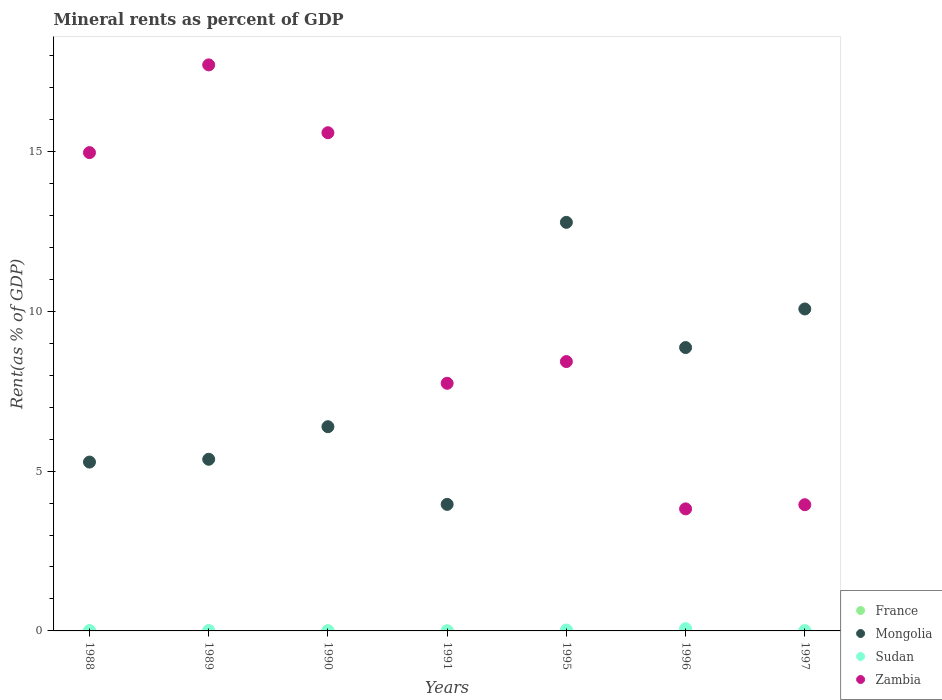What is the mineral rent in Sudan in 1991?
Your answer should be very brief. 0. Across all years, what is the maximum mineral rent in Mongolia?
Provide a succinct answer. 12.78. Across all years, what is the minimum mineral rent in Zambia?
Offer a very short reply. 3.82. In which year was the mineral rent in Sudan minimum?
Offer a terse response. 1991. What is the total mineral rent in Mongolia in the graph?
Provide a short and direct response. 52.72. What is the difference between the mineral rent in Sudan in 1991 and that in 1996?
Provide a short and direct response. -0.07. What is the difference between the mineral rent in France in 1989 and the mineral rent in Zambia in 1997?
Give a very brief answer. -3.94. What is the average mineral rent in France per year?
Ensure brevity in your answer.  0. In the year 1997, what is the difference between the mineral rent in Sudan and mineral rent in Zambia?
Keep it short and to the point. -3.94. In how many years, is the mineral rent in Zambia greater than 17 %?
Your response must be concise. 1. What is the ratio of the mineral rent in France in 1995 to that in 1997?
Your response must be concise. 3.13. Is the mineral rent in Mongolia in 1991 less than that in 1997?
Your response must be concise. Yes. Is the difference between the mineral rent in Sudan in 1988 and 1991 greater than the difference between the mineral rent in Zambia in 1988 and 1991?
Make the answer very short. No. What is the difference between the highest and the second highest mineral rent in Zambia?
Your answer should be very brief. 2.12. What is the difference between the highest and the lowest mineral rent in Sudan?
Your answer should be very brief. 0.07. In how many years, is the mineral rent in Sudan greater than the average mineral rent in Sudan taken over all years?
Provide a succinct answer. 2. Does the mineral rent in Mongolia monotonically increase over the years?
Make the answer very short. No. Is the mineral rent in France strictly less than the mineral rent in Sudan over the years?
Make the answer very short. No. How many years are there in the graph?
Make the answer very short. 7. What is the difference between two consecutive major ticks on the Y-axis?
Provide a short and direct response. 5. Where does the legend appear in the graph?
Your answer should be very brief. Bottom right. What is the title of the graph?
Offer a very short reply. Mineral rents as percent of GDP. What is the label or title of the Y-axis?
Provide a succinct answer. Rent(as % of GDP). What is the Rent(as % of GDP) of France in 1988?
Make the answer very short. 0. What is the Rent(as % of GDP) in Mongolia in 1988?
Offer a very short reply. 5.28. What is the Rent(as % of GDP) of Sudan in 1988?
Make the answer very short. 0.01. What is the Rent(as % of GDP) in Zambia in 1988?
Give a very brief answer. 14.96. What is the Rent(as % of GDP) of France in 1989?
Keep it short and to the point. 0. What is the Rent(as % of GDP) of Mongolia in 1989?
Give a very brief answer. 5.37. What is the Rent(as % of GDP) of Sudan in 1989?
Your response must be concise. 0.01. What is the Rent(as % of GDP) of Zambia in 1989?
Make the answer very short. 17.71. What is the Rent(as % of GDP) in France in 1990?
Your response must be concise. 0. What is the Rent(as % of GDP) of Mongolia in 1990?
Your response must be concise. 6.39. What is the Rent(as % of GDP) in Sudan in 1990?
Make the answer very short. 0. What is the Rent(as % of GDP) of Zambia in 1990?
Provide a short and direct response. 15.59. What is the Rent(as % of GDP) in France in 1991?
Offer a very short reply. 0. What is the Rent(as % of GDP) of Mongolia in 1991?
Ensure brevity in your answer.  3.96. What is the Rent(as % of GDP) of Sudan in 1991?
Offer a terse response. 0. What is the Rent(as % of GDP) of Zambia in 1991?
Make the answer very short. 7.75. What is the Rent(as % of GDP) of France in 1995?
Give a very brief answer. 0. What is the Rent(as % of GDP) of Mongolia in 1995?
Provide a short and direct response. 12.78. What is the Rent(as % of GDP) of Sudan in 1995?
Keep it short and to the point. 0.03. What is the Rent(as % of GDP) in Zambia in 1995?
Make the answer very short. 8.43. What is the Rent(as % of GDP) of France in 1996?
Your answer should be very brief. 0. What is the Rent(as % of GDP) of Mongolia in 1996?
Provide a short and direct response. 8.87. What is the Rent(as % of GDP) of Sudan in 1996?
Give a very brief answer. 0.07. What is the Rent(as % of GDP) in Zambia in 1996?
Your response must be concise. 3.82. What is the Rent(as % of GDP) of France in 1997?
Your response must be concise. 0. What is the Rent(as % of GDP) of Mongolia in 1997?
Your response must be concise. 10.07. What is the Rent(as % of GDP) in Sudan in 1997?
Offer a terse response. 0. What is the Rent(as % of GDP) in Zambia in 1997?
Offer a terse response. 3.95. Across all years, what is the maximum Rent(as % of GDP) in France?
Your response must be concise. 0. Across all years, what is the maximum Rent(as % of GDP) in Mongolia?
Your answer should be very brief. 12.78. Across all years, what is the maximum Rent(as % of GDP) in Sudan?
Offer a terse response. 0.07. Across all years, what is the maximum Rent(as % of GDP) in Zambia?
Ensure brevity in your answer.  17.71. Across all years, what is the minimum Rent(as % of GDP) of France?
Offer a terse response. 0. Across all years, what is the minimum Rent(as % of GDP) in Mongolia?
Provide a short and direct response. 3.96. Across all years, what is the minimum Rent(as % of GDP) of Sudan?
Keep it short and to the point. 0. Across all years, what is the minimum Rent(as % of GDP) of Zambia?
Offer a very short reply. 3.82. What is the total Rent(as % of GDP) of France in the graph?
Provide a short and direct response. 0.01. What is the total Rent(as % of GDP) of Mongolia in the graph?
Make the answer very short. 52.72. What is the total Rent(as % of GDP) of Sudan in the graph?
Give a very brief answer. 0.12. What is the total Rent(as % of GDP) in Zambia in the graph?
Offer a very short reply. 72.2. What is the difference between the Rent(as % of GDP) in France in 1988 and that in 1989?
Provide a succinct answer. -0. What is the difference between the Rent(as % of GDP) in Mongolia in 1988 and that in 1989?
Make the answer very short. -0.09. What is the difference between the Rent(as % of GDP) of Sudan in 1988 and that in 1989?
Provide a short and direct response. -0. What is the difference between the Rent(as % of GDP) of Zambia in 1988 and that in 1989?
Make the answer very short. -2.74. What is the difference between the Rent(as % of GDP) of France in 1988 and that in 1990?
Ensure brevity in your answer.  0. What is the difference between the Rent(as % of GDP) in Mongolia in 1988 and that in 1990?
Your answer should be compact. -1.11. What is the difference between the Rent(as % of GDP) of Sudan in 1988 and that in 1990?
Make the answer very short. 0.01. What is the difference between the Rent(as % of GDP) in Zambia in 1988 and that in 1990?
Your answer should be compact. -0.62. What is the difference between the Rent(as % of GDP) in France in 1988 and that in 1991?
Your response must be concise. 0. What is the difference between the Rent(as % of GDP) in Mongolia in 1988 and that in 1991?
Your answer should be very brief. 1.32. What is the difference between the Rent(as % of GDP) in Sudan in 1988 and that in 1991?
Ensure brevity in your answer.  0.01. What is the difference between the Rent(as % of GDP) of Zambia in 1988 and that in 1991?
Your response must be concise. 7.22. What is the difference between the Rent(as % of GDP) of France in 1988 and that in 1995?
Your answer should be compact. 0. What is the difference between the Rent(as % of GDP) of Mongolia in 1988 and that in 1995?
Ensure brevity in your answer.  -7.5. What is the difference between the Rent(as % of GDP) in Sudan in 1988 and that in 1995?
Ensure brevity in your answer.  -0.02. What is the difference between the Rent(as % of GDP) in Zambia in 1988 and that in 1995?
Your answer should be compact. 6.54. What is the difference between the Rent(as % of GDP) of France in 1988 and that in 1996?
Offer a terse response. 0. What is the difference between the Rent(as % of GDP) of Mongolia in 1988 and that in 1996?
Ensure brevity in your answer.  -3.58. What is the difference between the Rent(as % of GDP) of Sudan in 1988 and that in 1996?
Your response must be concise. -0.06. What is the difference between the Rent(as % of GDP) of Zambia in 1988 and that in 1996?
Offer a very short reply. 11.15. What is the difference between the Rent(as % of GDP) of France in 1988 and that in 1997?
Your answer should be compact. 0. What is the difference between the Rent(as % of GDP) of Mongolia in 1988 and that in 1997?
Offer a very short reply. -4.79. What is the difference between the Rent(as % of GDP) of Sudan in 1988 and that in 1997?
Give a very brief answer. 0. What is the difference between the Rent(as % of GDP) of Zambia in 1988 and that in 1997?
Your answer should be compact. 11.02. What is the difference between the Rent(as % of GDP) in France in 1989 and that in 1990?
Ensure brevity in your answer.  0. What is the difference between the Rent(as % of GDP) of Mongolia in 1989 and that in 1990?
Offer a terse response. -1.02. What is the difference between the Rent(as % of GDP) in Sudan in 1989 and that in 1990?
Provide a succinct answer. 0.01. What is the difference between the Rent(as % of GDP) of Zambia in 1989 and that in 1990?
Provide a succinct answer. 2.12. What is the difference between the Rent(as % of GDP) in France in 1989 and that in 1991?
Offer a terse response. 0. What is the difference between the Rent(as % of GDP) of Mongolia in 1989 and that in 1991?
Keep it short and to the point. 1.41. What is the difference between the Rent(as % of GDP) in Sudan in 1989 and that in 1991?
Your response must be concise. 0.01. What is the difference between the Rent(as % of GDP) of Zambia in 1989 and that in 1991?
Ensure brevity in your answer.  9.96. What is the difference between the Rent(as % of GDP) in France in 1989 and that in 1995?
Offer a very short reply. 0. What is the difference between the Rent(as % of GDP) of Mongolia in 1989 and that in 1995?
Ensure brevity in your answer.  -7.41. What is the difference between the Rent(as % of GDP) in Sudan in 1989 and that in 1995?
Provide a succinct answer. -0.02. What is the difference between the Rent(as % of GDP) of Zambia in 1989 and that in 1995?
Make the answer very short. 9.28. What is the difference between the Rent(as % of GDP) in France in 1989 and that in 1996?
Your answer should be very brief. 0. What is the difference between the Rent(as % of GDP) of Mongolia in 1989 and that in 1996?
Offer a very short reply. -3.5. What is the difference between the Rent(as % of GDP) in Sudan in 1989 and that in 1996?
Keep it short and to the point. -0.06. What is the difference between the Rent(as % of GDP) of Zambia in 1989 and that in 1996?
Provide a short and direct response. 13.89. What is the difference between the Rent(as % of GDP) of France in 1989 and that in 1997?
Provide a short and direct response. 0. What is the difference between the Rent(as % of GDP) in Mongolia in 1989 and that in 1997?
Your response must be concise. -4.7. What is the difference between the Rent(as % of GDP) in Sudan in 1989 and that in 1997?
Provide a short and direct response. 0. What is the difference between the Rent(as % of GDP) in Zambia in 1989 and that in 1997?
Provide a short and direct response. 13.76. What is the difference between the Rent(as % of GDP) in France in 1990 and that in 1991?
Give a very brief answer. 0. What is the difference between the Rent(as % of GDP) in Mongolia in 1990 and that in 1991?
Your response must be concise. 2.43. What is the difference between the Rent(as % of GDP) of Sudan in 1990 and that in 1991?
Make the answer very short. 0. What is the difference between the Rent(as % of GDP) of Zambia in 1990 and that in 1991?
Your answer should be compact. 7.84. What is the difference between the Rent(as % of GDP) of France in 1990 and that in 1995?
Provide a short and direct response. 0. What is the difference between the Rent(as % of GDP) in Mongolia in 1990 and that in 1995?
Give a very brief answer. -6.39. What is the difference between the Rent(as % of GDP) in Sudan in 1990 and that in 1995?
Provide a short and direct response. -0.03. What is the difference between the Rent(as % of GDP) of Zambia in 1990 and that in 1995?
Give a very brief answer. 7.16. What is the difference between the Rent(as % of GDP) of France in 1990 and that in 1996?
Your response must be concise. 0. What is the difference between the Rent(as % of GDP) in Mongolia in 1990 and that in 1996?
Provide a short and direct response. -2.48. What is the difference between the Rent(as % of GDP) of Sudan in 1990 and that in 1996?
Your response must be concise. -0.07. What is the difference between the Rent(as % of GDP) of Zambia in 1990 and that in 1996?
Your answer should be very brief. 11.77. What is the difference between the Rent(as % of GDP) of France in 1990 and that in 1997?
Your answer should be compact. 0. What is the difference between the Rent(as % of GDP) of Mongolia in 1990 and that in 1997?
Offer a very short reply. -3.68. What is the difference between the Rent(as % of GDP) of Sudan in 1990 and that in 1997?
Provide a succinct answer. -0. What is the difference between the Rent(as % of GDP) of Zambia in 1990 and that in 1997?
Your response must be concise. 11.64. What is the difference between the Rent(as % of GDP) of France in 1991 and that in 1995?
Provide a short and direct response. 0. What is the difference between the Rent(as % of GDP) in Mongolia in 1991 and that in 1995?
Your response must be concise. -8.82. What is the difference between the Rent(as % of GDP) of Sudan in 1991 and that in 1995?
Ensure brevity in your answer.  -0.03. What is the difference between the Rent(as % of GDP) in Zambia in 1991 and that in 1995?
Keep it short and to the point. -0.68. What is the difference between the Rent(as % of GDP) of France in 1991 and that in 1996?
Offer a very short reply. 0. What is the difference between the Rent(as % of GDP) in Mongolia in 1991 and that in 1996?
Offer a terse response. -4.91. What is the difference between the Rent(as % of GDP) of Sudan in 1991 and that in 1996?
Your response must be concise. -0.07. What is the difference between the Rent(as % of GDP) of Zambia in 1991 and that in 1996?
Ensure brevity in your answer.  3.93. What is the difference between the Rent(as % of GDP) in France in 1991 and that in 1997?
Provide a succinct answer. 0. What is the difference between the Rent(as % of GDP) of Mongolia in 1991 and that in 1997?
Your answer should be compact. -6.11. What is the difference between the Rent(as % of GDP) in Sudan in 1991 and that in 1997?
Give a very brief answer. -0. What is the difference between the Rent(as % of GDP) of Zambia in 1991 and that in 1997?
Offer a very short reply. 3.8. What is the difference between the Rent(as % of GDP) in France in 1995 and that in 1996?
Your response must be concise. -0. What is the difference between the Rent(as % of GDP) of Mongolia in 1995 and that in 1996?
Provide a succinct answer. 3.92. What is the difference between the Rent(as % of GDP) in Sudan in 1995 and that in 1996?
Your answer should be very brief. -0.04. What is the difference between the Rent(as % of GDP) of Zambia in 1995 and that in 1996?
Keep it short and to the point. 4.61. What is the difference between the Rent(as % of GDP) in Mongolia in 1995 and that in 1997?
Give a very brief answer. 2.71. What is the difference between the Rent(as % of GDP) of Sudan in 1995 and that in 1997?
Your answer should be compact. 0.02. What is the difference between the Rent(as % of GDP) of Zambia in 1995 and that in 1997?
Keep it short and to the point. 4.48. What is the difference between the Rent(as % of GDP) in France in 1996 and that in 1997?
Provide a succinct answer. 0. What is the difference between the Rent(as % of GDP) of Mongolia in 1996 and that in 1997?
Offer a terse response. -1.21. What is the difference between the Rent(as % of GDP) of Sudan in 1996 and that in 1997?
Provide a succinct answer. 0.07. What is the difference between the Rent(as % of GDP) of Zambia in 1996 and that in 1997?
Your response must be concise. -0.13. What is the difference between the Rent(as % of GDP) of France in 1988 and the Rent(as % of GDP) of Mongolia in 1989?
Provide a short and direct response. -5.37. What is the difference between the Rent(as % of GDP) of France in 1988 and the Rent(as % of GDP) of Sudan in 1989?
Your response must be concise. -0. What is the difference between the Rent(as % of GDP) in France in 1988 and the Rent(as % of GDP) in Zambia in 1989?
Your answer should be very brief. -17.71. What is the difference between the Rent(as % of GDP) in Mongolia in 1988 and the Rent(as % of GDP) in Sudan in 1989?
Provide a succinct answer. 5.27. What is the difference between the Rent(as % of GDP) in Mongolia in 1988 and the Rent(as % of GDP) in Zambia in 1989?
Your answer should be compact. -12.43. What is the difference between the Rent(as % of GDP) of Sudan in 1988 and the Rent(as % of GDP) of Zambia in 1989?
Offer a terse response. -17.7. What is the difference between the Rent(as % of GDP) in France in 1988 and the Rent(as % of GDP) in Mongolia in 1990?
Offer a terse response. -6.39. What is the difference between the Rent(as % of GDP) of France in 1988 and the Rent(as % of GDP) of Sudan in 1990?
Ensure brevity in your answer.  0. What is the difference between the Rent(as % of GDP) of France in 1988 and the Rent(as % of GDP) of Zambia in 1990?
Offer a terse response. -15.58. What is the difference between the Rent(as % of GDP) of Mongolia in 1988 and the Rent(as % of GDP) of Sudan in 1990?
Your answer should be compact. 5.28. What is the difference between the Rent(as % of GDP) in Mongolia in 1988 and the Rent(as % of GDP) in Zambia in 1990?
Make the answer very short. -10.3. What is the difference between the Rent(as % of GDP) in Sudan in 1988 and the Rent(as % of GDP) in Zambia in 1990?
Make the answer very short. -15.58. What is the difference between the Rent(as % of GDP) in France in 1988 and the Rent(as % of GDP) in Mongolia in 1991?
Provide a succinct answer. -3.96. What is the difference between the Rent(as % of GDP) of France in 1988 and the Rent(as % of GDP) of Sudan in 1991?
Ensure brevity in your answer.  0. What is the difference between the Rent(as % of GDP) in France in 1988 and the Rent(as % of GDP) in Zambia in 1991?
Make the answer very short. -7.74. What is the difference between the Rent(as % of GDP) in Mongolia in 1988 and the Rent(as % of GDP) in Sudan in 1991?
Offer a very short reply. 5.28. What is the difference between the Rent(as % of GDP) in Mongolia in 1988 and the Rent(as % of GDP) in Zambia in 1991?
Your answer should be compact. -2.46. What is the difference between the Rent(as % of GDP) in Sudan in 1988 and the Rent(as % of GDP) in Zambia in 1991?
Offer a terse response. -7.74. What is the difference between the Rent(as % of GDP) in France in 1988 and the Rent(as % of GDP) in Mongolia in 1995?
Give a very brief answer. -12.78. What is the difference between the Rent(as % of GDP) in France in 1988 and the Rent(as % of GDP) in Sudan in 1995?
Provide a short and direct response. -0.03. What is the difference between the Rent(as % of GDP) in France in 1988 and the Rent(as % of GDP) in Zambia in 1995?
Provide a short and direct response. -8.42. What is the difference between the Rent(as % of GDP) in Mongolia in 1988 and the Rent(as % of GDP) in Sudan in 1995?
Make the answer very short. 5.25. What is the difference between the Rent(as % of GDP) in Mongolia in 1988 and the Rent(as % of GDP) in Zambia in 1995?
Keep it short and to the point. -3.14. What is the difference between the Rent(as % of GDP) of Sudan in 1988 and the Rent(as % of GDP) of Zambia in 1995?
Your response must be concise. -8.42. What is the difference between the Rent(as % of GDP) in France in 1988 and the Rent(as % of GDP) in Mongolia in 1996?
Offer a very short reply. -8.86. What is the difference between the Rent(as % of GDP) in France in 1988 and the Rent(as % of GDP) in Sudan in 1996?
Offer a terse response. -0.07. What is the difference between the Rent(as % of GDP) of France in 1988 and the Rent(as % of GDP) of Zambia in 1996?
Your answer should be very brief. -3.81. What is the difference between the Rent(as % of GDP) in Mongolia in 1988 and the Rent(as % of GDP) in Sudan in 1996?
Your answer should be very brief. 5.21. What is the difference between the Rent(as % of GDP) in Mongolia in 1988 and the Rent(as % of GDP) in Zambia in 1996?
Ensure brevity in your answer.  1.46. What is the difference between the Rent(as % of GDP) of Sudan in 1988 and the Rent(as % of GDP) of Zambia in 1996?
Offer a very short reply. -3.81. What is the difference between the Rent(as % of GDP) in France in 1988 and the Rent(as % of GDP) in Mongolia in 1997?
Provide a succinct answer. -10.07. What is the difference between the Rent(as % of GDP) of France in 1988 and the Rent(as % of GDP) of Sudan in 1997?
Your response must be concise. -0. What is the difference between the Rent(as % of GDP) in France in 1988 and the Rent(as % of GDP) in Zambia in 1997?
Keep it short and to the point. -3.94. What is the difference between the Rent(as % of GDP) of Mongolia in 1988 and the Rent(as % of GDP) of Sudan in 1997?
Ensure brevity in your answer.  5.28. What is the difference between the Rent(as % of GDP) in Mongolia in 1988 and the Rent(as % of GDP) in Zambia in 1997?
Your answer should be compact. 1.33. What is the difference between the Rent(as % of GDP) in Sudan in 1988 and the Rent(as % of GDP) in Zambia in 1997?
Keep it short and to the point. -3.94. What is the difference between the Rent(as % of GDP) of France in 1989 and the Rent(as % of GDP) of Mongolia in 1990?
Provide a succinct answer. -6.38. What is the difference between the Rent(as % of GDP) of France in 1989 and the Rent(as % of GDP) of Sudan in 1990?
Your answer should be very brief. 0. What is the difference between the Rent(as % of GDP) of France in 1989 and the Rent(as % of GDP) of Zambia in 1990?
Give a very brief answer. -15.58. What is the difference between the Rent(as % of GDP) of Mongolia in 1989 and the Rent(as % of GDP) of Sudan in 1990?
Your answer should be compact. 5.37. What is the difference between the Rent(as % of GDP) in Mongolia in 1989 and the Rent(as % of GDP) in Zambia in 1990?
Offer a terse response. -10.22. What is the difference between the Rent(as % of GDP) of Sudan in 1989 and the Rent(as % of GDP) of Zambia in 1990?
Provide a short and direct response. -15.58. What is the difference between the Rent(as % of GDP) in France in 1989 and the Rent(as % of GDP) in Mongolia in 1991?
Provide a succinct answer. -3.96. What is the difference between the Rent(as % of GDP) in France in 1989 and the Rent(as % of GDP) in Sudan in 1991?
Offer a very short reply. 0. What is the difference between the Rent(as % of GDP) of France in 1989 and the Rent(as % of GDP) of Zambia in 1991?
Offer a very short reply. -7.74. What is the difference between the Rent(as % of GDP) of Mongolia in 1989 and the Rent(as % of GDP) of Sudan in 1991?
Your answer should be compact. 5.37. What is the difference between the Rent(as % of GDP) of Mongolia in 1989 and the Rent(as % of GDP) of Zambia in 1991?
Offer a terse response. -2.38. What is the difference between the Rent(as % of GDP) of Sudan in 1989 and the Rent(as % of GDP) of Zambia in 1991?
Provide a succinct answer. -7.74. What is the difference between the Rent(as % of GDP) in France in 1989 and the Rent(as % of GDP) in Mongolia in 1995?
Ensure brevity in your answer.  -12.78. What is the difference between the Rent(as % of GDP) of France in 1989 and the Rent(as % of GDP) of Sudan in 1995?
Provide a short and direct response. -0.03. What is the difference between the Rent(as % of GDP) in France in 1989 and the Rent(as % of GDP) in Zambia in 1995?
Offer a very short reply. -8.42. What is the difference between the Rent(as % of GDP) of Mongolia in 1989 and the Rent(as % of GDP) of Sudan in 1995?
Offer a very short reply. 5.34. What is the difference between the Rent(as % of GDP) of Mongolia in 1989 and the Rent(as % of GDP) of Zambia in 1995?
Your response must be concise. -3.06. What is the difference between the Rent(as % of GDP) in Sudan in 1989 and the Rent(as % of GDP) in Zambia in 1995?
Your answer should be compact. -8.42. What is the difference between the Rent(as % of GDP) of France in 1989 and the Rent(as % of GDP) of Mongolia in 1996?
Offer a very short reply. -8.86. What is the difference between the Rent(as % of GDP) in France in 1989 and the Rent(as % of GDP) in Sudan in 1996?
Your answer should be compact. -0.07. What is the difference between the Rent(as % of GDP) of France in 1989 and the Rent(as % of GDP) of Zambia in 1996?
Your answer should be very brief. -3.81. What is the difference between the Rent(as % of GDP) in Mongolia in 1989 and the Rent(as % of GDP) in Sudan in 1996?
Provide a short and direct response. 5.3. What is the difference between the Rent(as % of GDP) in Mongolia in 1989 and the Rent(as % of GDP) in Zambia in 1996?
Your response must be concise. 1.55. What is the difference between the Rent(as % of GDP) of Sudan in 1989 and the Rent(as % of GDP) of Zambia in 1996?
Keep it short and to the point. -3.81. What is the difference between the Rent(as % of GDP) of France in 1989 and the Rent(as % of GDP) of Mongolia in 1997?
Your response must be concise. -10.07. What is the difference between the Rent(as % of GDP) of France in 1989 and the Rent(as % of GDP) of Sudan in 1997?
Keep it short and to the point. -0. What is the difference between the Rent(as % of GDP) in France in 1989 and the Rent(as % of GDP) in Zambia in 1997?
Provide a short and direct response. -3.94. What is the difference between the Rent(as % of GDP) in Mongolia in 1989 and the Rent(as % of GDP) in Sudan in 1997?
Give a very brief answer. 5.37. What is the difference between the Rent(as % of GDP) of Mongolia in 1989 and the Rent(as % of GDP) of Zambia in 1997?
Offer a terse response. 1.42. What is the difference between the Rent(as % of GDP) of Sudan in 1989 and the Rent(as % of GDP) of Zambia in 1997?
Your answer should be compact. -3.94. What is the difference between the Rent(as % of GDP) in France in 1990 and the Rent(as % of GDP) in Mongolia in 1991?
Ensure brevity in your answer.  -3.96. What is the difference between the Rent(as % of GDP) in France in 1990 and the Rent(as % of GDP) in Sudan in 1991?
Provide a succinct answer. 0. What is the difference between the Rent(as % of GDP) in France in 1990 and the Rent(as % of GDP) in Zambia in 1991?
Provide a short and direct response. -7.75. What is the difference between the Rent(as % of GDP) in Mongolia in 1990 and the Rent(as % of GDP) in Sudan in 1991?
Offer a terse response. 6.39. What is the difference between the Rent(as % of GDP) of Mongolia in 1990 and the Rent(as % of GDP) of Zambia in 1991?
Ensure brevity in your answer.  -1.36. What is the difference between the Rent(as % of GDP) of Sudan in 1990 and the Rent(as % of GDP) of Zambia in 1991?
Keep it short and to the point. -7.75. What is the difference between the Rent(as % of GDP) in France in 1990 and the Rent(as % of GDP) in Mongolia in 1995?
Your answer should be compact. -12.78. What is the difference between the Rent(as % of GDP) of France in 1990 and the Rent(as % of GDP) of Sudan in 1995?
Offer a very short reply. -0.03. What is the difference between the Rent(as % of GDP) of France in 1990 and the Rent(as % of GDP) of Zambia in 1995?
Keep it short and to the point. -8.42. What is the difference between the Rent(as % of GDP) in Mongolia in 1990 and the Rent(as % of GDP) in Sudan in 1995?
Your answer should be very brief. 6.36. What is the difference between the Rent(as % of GDP) of Mongolia in 1990 and the Rent(as % of GDP) of Zambia in 1995?
Provide a succinct answer. -2.04. What is the difference between the Rent(as % of GDP) in Sudan in 1990 and the Rent(as % of GDP) in Zambia in 1995?
Give a very brief answer. -8.42. What is the difference between the Rent(as % of GDP) in France in 1990 and the Rent(as % of GDP) in Mongolia in 1996?
Your answer should be compact. -8.86. What is the difference between the Rent(as % of GDP) of France in 1990 and the Rent(as % of GDP) of Sudan in 1996?
Your response must be concise. -0.07. What is the difference between the Rent(as % of GDP) in France in 1990 and the Rent(as % of GDP) in Zambia in 1996?
Ensure brevity in your answer.  -3.82. What is the difference between the Rent(as % of GDP) of Mongolia in 1990 and the Rent(as % of GDP) of Sudan in 1996?
Your answer should be very brief. 6.32. What is the difference between the Rent(as % of GDP) of Mongolia in 1990 and the Rent(as % of GDP) of Zambia in 1996?
Ensure brevity in your answer.  2.57. What is the difference between the Rent(as % of GDP) of Sudan in 1990 and the Rent(as % of GDP) of Zambia in 1996?
Offer a terse response. -3.82. What is the difference between the Rent(as % of GDP) of France in 1990 and the Rent(as % of GDP) of Mongolia in 1997?
Give a very brief answer. -10.07. What is the difference between the Rent(as % of GDP) in France in 1990 and the Rent(as % of GDP) in Sudan in 1997?
Keep it short and to the point. -0. What is the difference between the Rent(as % of GDP) in France in 1990 and the Rent(as % of GDP) in Zambia in 1997?
Keep it short and to the point. -3.95. What is the difference between the Rent(as % of GDP) in Mongolia in 1990 and the Rent(as % of GDP) in Sudan in 1997?
Your answer should be compact. 6.38. What is the difference between the Rent(as % of GDP) of Mongolia in 1990 and the Rent(as % of GDP) of Zambia in 1997?
Offer a very short reply. 2.44. What is the difference between the Rent(as % of GDP) in Sudan in 1990 and the Rent(as % of GDP) in Zambia in 1997?
Keep it short and to the point. -3.95. What is the difference between the Rent(as % of GDP) in France in 1991 and the Rent(as % of GDP) in Mongolia in 1995?
Your answer should be very brief. -12.78. What is the difference between the Rent(as % of GDP) of France in 1991 and the Rent(as % of GDP) of Sudan in 1995?
Ensure brevity in your answer.  -0.03. What is the difference between the Rent(as % of GDP) in France in 1991 and the Rent(as % of GDP) in Zambia in 1995?
Your response must be concise. -8.43. What is the difference between the Rent(as % of GDP) in Mongolia in 1991 and the Rent(as % of GDP) in Sudan in 1995?
Ensure brevity in your answer.  3.93. What is the difference between the Rent(as % of GDP) in Mongolia in 1991 and the Rent(as % of GDP) in Zambia in 1995?
Provide a succinct answer. -4.47. What is the difference between the Rent(as % of GDP) of Sudan in 1991 and the Rent(as % of GDP) of Zambia in 1995?
Your response must be concise. -8.43. What is the difference between the Rent(as % of GDP) of France in 1991 and the Rent(as % of GDP) of Mongolia in 1996?
Provide a succinct answer. -8.86. What is the difference between the Rent(as % of GDP) in France in 1991 and the Rent(as % of GDP) in Sudan in 1996?
Your answer should be compact. -0.07. What is the difference between the Rent(as % of GDP) in France in 1991 and the Rent(as % of GDP) in Zambia in 1996?
Ensure brevity in your answer.  -3.82. What is the difference between the Rent(as % of GDP) of Mongolia in 1991 and the Rent(as % of GDP) of Sudan in 1996?
Your answer should be very brief. 3.89. What is the difference between the Rent(as % of GDP) of Mongolia in 1991 and the Rent(as % of GDP) of Zambia in 1996?
Provide a short and direct response. 0.14. What is the difference between the Rent(as % of GDP) in Sudan in 1991 and the Rent(as % of GDP) in Zambia in 1996?
Your answer should be compact. -3.82. What is the difference between the Rent(as % of GDP) in France in 1991 and the Rent(as % of GDP) in Mongolia in 1997?
Your answer should be very brief. -10.07. What is the difference between the Rent(as % of GDP) of France in 1991 and the Rent(as % of GDP) of Sudan in 1997?
Your answer should be very brief. -0. What is the difference between the Rent(as % of GDP) in France in 1991 and the Rent(as % of GDP) in Zambia in 1997?
Your answer should be very brief. -3.95. What is the difference between the Rent(as % of GDP) in Mongolia in 1991 and the Rent(as % of GDP) in Sudan in 1997?
Your answer should be very brief. 3.95. What is the difference between the Rent(as % of GDP) in Mongolia in 1991 and the Rent(as % of GDP) in Zambia in 1997?
Your answer should be very brief. 0.01. What is the difference between the Rent(as % of GDP) of Sudan in 1991 and the Rent(as % of GDP) of Zambia in 1997?
Ensure brevity in your answer.  -3.95. What is the difference between the Rent(as % of GDP) in France in 1995 and the Rent(as % of GDP) in Mongolia in 1996?
Keep it short and to the point. -8.87. What is the difference between the Rent(as % of GDP) of France in 1995 and the Rent(as % of GDP) of Sudan in 1996?
Provide a short and direct response. -0.07. What is the difference between the Rent(as % of GDP) of France in 1995 and the Rent(as % of GDP) of Zambia in 1996?
Provide a short and direct response. -3.82. What is the difference between the Rent(as % of GDP) in Mongolia in 1995 and the Rent(as % of GDP) in Sudan in 1996?
Your answer should be very brief. 12.71. What is the difference between the Rent(as % of GDP) in Mongolia in 1995 and the Rent(as % of GDP) in Zambia in 1996?
Your response must be concise. 8.96. What is the difference between the Rent(as % of GDP) of Sudan in 1995 and the Rent(as % of GDP) of Zambia in 1996?
Provide a succinct answer. -3.79. What is the difference between the Rent(as % of GDP) in France in 1995 and the Rent(as % of GDP) in Mongolia in 1997?
Keep it short and to the point. -10.07. What is the difference between the Rent(as % of GDP) in France in 1995 and the Rent(as % of GDP) in Sudan in 1997?
Your answer should be very brief. -0. What is the difference between the Rent(as % of GDP) of France in 1995 and the Rent(as % of GDP) of Zambia in 1997?
Offer a terse response. -3.95. What is the difference between the Rent(as % of GDP) of Mongolia in 1995 and the Rent(as % of GDP) of Sudan in 1997?
Provide a short and direct response. 12.78. What is the difference between the Rent(as % of GDP) of Mongolia in 1995 and the Rent(as % of GDP) of Zambia in 1997?
Provide a succinct answer. 8.83. What is the difference between the Rent(as % of GDP) in Sudan in 1995 and the Rent(as % of GDP) in Zambia in 1997?
Provide a succinct answer. -3.92. What is the difference between the Rent(as % of GDP) in France in 1996 and the Rent(as % of GDP) in Mongolia in 1997?
Ensure brevity in your answer.  -10.07. What is the difference between the Rent(as % of GDP) of France in 1996 and the Rent(as % of GDP) of Sudan in 1997?
Offer a terse response. -0. What is the difference between the Rent(as % of GDP) in France in 1996 and the Rent(as % of GDP) in Zambia in 1997?
Provide a succinct answer. -3.95. What is the difference between the Rent(as % of GDP) in Mongolia in 1996 and the Rent(as % of GDP) in Sudan in 1997?
Give a very brief answer. 8.86. What is the difference between the Rent(as % of GDP) in Mongolia in 1996 and the Rent(as % of GDP) in Zambia in 1997?
Offer a very short reply. 4.92. What is the difference between the Rent(as % of GDP) of Sudan in 1996 and the Rent(as % of GDP) of Zambia in 1997?
Offer a very short reply. -3.88. What is the average Rent(as % of GDP) of France per year?
Make the answer very short. 0. What is the average Rent(as % of GDP) in Mongolia per year?
Offer a very short reply. 7.53. What is the average Rent(as % of GDP) in Sudan per year?
Make the answer very short. 0.02. What is the average Rent(as % of GDP) of Zambia per year?
Ensure brevity in your answer.  10.31. In the year 1988, what is the difference between the Rent(as % of GDP) of France and Rent(as % of GDP) of Mongolia?
Give a very brief answer. -5.28. In the year 1988, what is the difference between the Rent(as % of GDP) of France and Rent(as % of GDP) of Sudan?
Your answer should be compact. -0. In the year 1988, what is the difference between the Rent(as % of GDP) of France and Rent(as % of GDP) of Zambia?
Provide a succinct answer. -14.96. In the year 1988, what is the difference between the Rent(as % of GDP) in Mongolia and Rent(as % of GDP) in Sudan?
Provide a succinct answer. 5.27. In the year 1988, what is the difference between the Rent(as % of GDP) in Mongolia and Rent(as % of GDP) in Zambia?
Give a very brief answer. -9.68. In the year 1988, what is the difference between the Rent(as % of GDP) in Sudan and Rent(as % of GDP) in Zambia?
Give a very brief answer. -14.96. In the year 1989, what is the difference between the Rent(as % of GDP) in France and Rent(as % of GDP) in Mongolia?
Keep it short and to the point. -5.37. In the year 1989, what is the difference between the Rent(as % of GDP) in France and Rent(as % of GDP) in Sudan?
Make the answer very short. -0. In the year 1989, what is the difference between the Rent(as % of GDP) in France and Rent(as % of GDP) in Zambia?
Your answer should be very brief. -17.7. In the year 1989, what is the difference between the Rent(as % of GDP) of Mongolia and Rent(as % of GDP) of Sudan?
Your answer should be compact. 5.36. In the year 1989, what is the difference between the Rent(as % of GDP) of Mongolia and Rent(as % of GDP) of Zambia?
Provide a succinct answer. -12.34. In the year 1989, what is the difference between the Rent(as % of GDP) in Sudan and Rent(as % of GDP) in Zambia?
Your answer should be compact. -17.7. In the year 1990, what is the difference between the Rent(as % of GDP) of France and Rent(as % of GDP) of Mongolia?
Offer a terse response. -6.39. In the year 1990, what is the difference between the Rent(as % of GDP) in France and Rent(as % of GDP) in Sudan?
Provide a succinct answer. 0. In the year 1990, what is the difference between the Rent(as % of GDP) of France and Rent(as % of GDP) of Zambia?
Your answer should be very brief. -15.58. In the year 1990, what is the difference between the Rent(as % of GDP) in Mongolia and Rent(as % of GDP) in Sudan?
Offer a terse response. 6.39. In the year 1990, what is the difference between the Rent(as % of GDP) in Mongolia and Rent(as % of GDP) in Zambia?
Offer a terse response. -9.2. In the year 1990, what is the difference between the Rent(as % of GDP) in Sudan and Rent(as % of GDP) in Zambia?
Give a very brief answer. -15.58. In the year 1991, what is the difference between the Rent(as % of GDP) in France and Rent(as % of GDP) in Mongolia?
Ensure brevity in your answer.  -3.96. In the year 1991, what is the difference between the Rent(as % of GDP) in France and Rent(as % of GDP) in Zambia?
Provide a short and direct response. -7.75. In the year 1991, what is the difference between the Rent(as % of GDP) in Mongolia and Rent(as % of GDP) in Sudan?
Ensure brevity in your answer.  3.96. In the year 1991, what is the difference between the Rent(as % of GDP) in Mongolia and Rent(as % of GDP) in Zambia?
Make the answer very short. -3.79. In the year 1991, what is the difference between the Rent(as % of GDP) of Sudan and Rent(as % of GDP) of Zambia?
Offer a terse response. -7.75. In the year 1995, what is the difference between the Rent(as % of GDP) in France and Rent(as % of GDP) in Mongolia?
Your answer should be very brief. -12.78. In the year 1995, what is the difference between the Rent(as % of GDP) of France and Rent(as % of GDP) of Sudan?
Offer a very short reply. -0.03. In the year 1995, what is the difference between the Rent(as % of GDP) of France and Rent(as % of GDP) of Zambia?
Your answer should be very brief. -8.43. In the year 1995, what is the difference between the Rent(as % of GDP) in Mongolia and Rent(as % of GDP) in Sudan?
Keep it short and to the point. 12.75. In the year 1995, what is the difference between the Rent(as % of GDP) of Mongolia and Rent(as % of GDP) of Zambia?
Offer a very short reply. 4.36. In the year 1995, what is the difference between the Rent(as % of GDP) of Sudan and Rent(as % of GDP) of Zambia?
Give a very brief answer. -8.4. In the year 1996, what is the difference between the Rent(as % of GDP) of France and Rent(as % of GDP) of Mongolia?
Your response must be concise. -8.86. In the year 1996, what is the difference between the Rent(as % of GDP) in France and Rent(as % of GDP) in Sudan?
Make the answer very short. -0.07. In the year 1996, what is the difference between the Rent(as % of GDP) of France and Rent(as % of GDP) of Zambia?
Keep it short and to the point. -3.82. In the year 1996, what is the difference between the Rent(as % of GDP) in Mongolia and Rent(as % of GDP) in Sudan?
Provide a short and direct response. 8.79. In the year 1996, what is the difference between the Rent(as % of GDP) of Mongolia and Rent(as % of GDP) of Zambia?
Offer a terse response. 5.05. In the year 1996, what is the difference between the Rent(as % of GDP) in Sudan and Rent(as % of GDP) in Zambia?
Keep it short and to the point. -3.75. In the year 1997, what is the difference between the Rent(as % of GDP) of France and Rent(as % of GDP) of Mongolia?
Give a very brief answer. -10.07. In the year 1997, what is the difference between the Rent(as % of GDP) in France and Rent(as % of GDP) in Sudan?
Provide a short and direct response. -0. In the year 1997, what is the difference between the Rent(as % of GDP) in France and Rent(as % of GDP) in Zambia?
Keep it short and to the point. -3.95. In the year 1997, what is the difference between the Rent(as % of GDP) of Mongolia and Rent(as % of GDP) of Sudan?
Give a very brief answer. 10.07. In the year 1997, what is the difference between the Rent(as % of GDP) in Mongolia and Rent(as % of GDP) in Zambia?
Your answer should be very brief. 6.12. In the year 1997, what is the difference between the Rent(as % of GDP) of Sudan and Rent(as % of GDP) of Zambia?
Offer a terse response. -3.94. What is the ratio of the Rent(as % of GDP) of France in 1988 to that in 1989?
Provide a short and direct response. 0.93. What is the ratio of the Rent(as % of GDP) in Mongolia in 1988 to that in 1989?
Your answer should be compact. 0.98. What is the ratio of the Rent(as % of GDP) of Sudan in 1988 to that in 1989?
Your answer should be compact. 1. What is the ratio of the Rent(as % of GDP) in Zambia in 1988 to that in 1989?
Your answer should be compact. 0.84. What is the ratio of the Rent(as % of GDP) in France in 1988 to that in 1990?
Your answer should be very brief. 1.66. What is the ratio of the Rent(as % of GDP) of Mongolia in 1988 to that in 1990?
Provide a succinct answer. 0.83. What is the ratio of the Rent(as % of GDP) in Sudan in 1988 to that in 1990?
Offer a very short reply. 4.62. What is the ratio of the Rent(as % of GDP) of Zambia in 1988 to that in 1990?
Provide a short and direct response. 0.96. What is the ratio of the Rent(as % of GDP) in France in 1988 to that in 1991?
Your answer should be compact. 3.78. What is the ratio of the Rent(as % of GDP) in Mongolia in 1988 to that in 1991?
Give a very brief answer. 1.33. What is the ratio of the Rent(as % of GDP) of Sudan in 1988 to that in 1991?
Offer a very short reply. 11.58. What is the ratio of the Rent(as % of GDP) of Zambia in 1988 to that in 1991?
Provide a short and direct response. 1.93. What is the ratio of the Rent(as % of GDP) in France in 1988 to that in 1995?
Provide a short and direct response. 9.5. What is the ratio of the Rent(as % of GDP) of Mongolia in 1988 to that in 1995?
Ensure brevity in your answer.  0.41. What is the ratio of the Rent(as % of GDP) in Sudan in 1988 to that in 1995?
Offer a very short reply. 0.28. What is the ratio of the Rent(as % of GDP) in Zambia in 1988 to that in 1995?
Provide a succinct answer. 1.78. What is the ratio of the Rent(as % of GDP) of France in 1988 to that in 1996?
Offer a very short reply. 6. What is the ratio of the Rent(as % of GDP) of Mongolia in 1988 to that in 1996?
Provide a succinct answer. 0.6. What is the ratio of the Rent(as % of GDP) of Sudan in 1988 to that in 1996?
Your answer should be compact. 0.12. What is the ratio of the Rent(as % of GDP) in Zambia in 1988 to that in 1996?
Your response must be concise. 3.92. What is the ratio of the Rent(as % of GDP) in France in 1988 to that in 1997?
Provide a succinct answer. 29.69. What is the ratio of the Rent(as % of GDP) in Mongolia in 1988 to that in 1997?
Your response must be concise. 0.52. What is the ratio of the Rent(as % of GDP) of Sudan in 1988 to that in 1997?
Your response must be concise. 1.73. What is the ratio of the Rent(as % of GDP) of Zambia in 1988 to that in 1997?
Provide a short and direct response. 3.79. What is the ratio of the Rent(as % of GDP) in France in 1989 to that in 1990?
Ensure brevity in your answer.  1.78. What is the ratio of the Rent(as % of GDP) in Mongolia in 1989 to that in 1990?
Provide a succinct answer. 0.84. What is the ratio of the Rent(as % of GDP) in Sudan in 1989 to that in 1990?
Your answer should be very brief. 4.62. What is the ratio of the Rent(as % of GDP) in Zambia in 1989 to that in 1990?
Your answer should be very brief. 1.14. What is the ratio of the Rent(as % of GDP) of France in 1989 to that in 1991?
Keep it short and to the point. 4.05. What is the ratio of the Rent(as % of GDP) in Mongolia in 1989 to that in 1991?
Offer a very short reply. 1.36. What is the ratio of the Rent(as % of GDP) of Sudan in 1989 to that in 1991?
Keep it short and to the point. 11.58. What is the ratio of the Rent(as % of GDP) in Zambia in 1989 to that in 1991?
Your response must be concise. 2.29. What is the ratio of the Rent(as % of GDP) of France in 1989 to that in 1995?
Your response must be concise. 10.16. What is the ratio of the Rent(as % of GDP) in Mongolia in 1989 to that in 1995?
Your response must be concise. 0.42. What is the ratio of the Rent(as % of GDP) in Sudan in 1989 to that in 1995?
Offer a very short reply. 0.28. What is the ratio of the Rent(as % of GDP) of Zambia in 1989 to that in 1995?
Make the answer very short. 2.1. What is the ratio of the Rent(as % of GDP) in France in 1989 to that in 1996?
Provide a succinct answer. 6.42. What is the ratio of the Rent(as % of GDP) in Mongolia in 1989 to that in 1996?
Your answer should be very brief. 0.61. What is the ratio of the Rent(as % of GDP) in Sudan in 1989 to that in 1996?
Your response must be concise. 0.12. What is the ratio of the Rent(as % of GDP) in Zambia in 1989 to that in 1996?
Ensure brevity in your answer.  4.64. What is the ratio of the Rent(as % of GDP) of France in 1989 to that in 1997?
Give a very brief answer. 31.76. What is the ratio of the Rent(as % of GDP) in Mongolia in 1989 to that in 1997?
Give a very brief answer. 0.53. What is the ratio of the Rent(as % of GDP) of Sudan in 1989 to that in 1997?
Offer a very short reply. 1.73. What is the ratio of the Rent(as % of GDP) in Zambia in 1989 to that in 1997?
Offer a terse response. 4.49. What is the ratio of the Rent(as % of GDP) in France in 1990 to that in 1991?
Keep it short and to the point. 2.27. What is the ratio of the Rent(as % of GDP) in Mongolia in 1990 to that in 1991?
Provide a short and direct response. 1.61. What is the ratio of the Rent(as % of GDP) of Sudan in 1990 to that in 1991?
Offer a terse response. 2.51. What is the ratio of the Rent(as % of GDP) in Zambia in 1990 to that in 1991?
Provide a short and direct response. 2.01. What is the ratio of the Rent(as % of GDP) in France in 1990 to that in 1995?
Provide a short and direct response. 5.7. What is the ratio of the Rent(as % of GDP) in Mongolia in 1990 to that in 1995?
Provide a succinct answer. 0.5. What is the ratio of the Rent(as % of GDP) of Sudan in 1990 to that in 1995?
Provide a succinct answer. 0.06. What is the ratio of the Rent(as % of GDP) in Zambia in 1990 to that in 1995?
Provide a succinct answer. 1.85. What is the ratio of the Rent(as % of GDP) of France in 1990 to that in 1996?
Offer a very short reply. 3.61. What is the ratio of the Rent(as % of GDP) in Mongolia in 1990 to that in 1996?
Your response must be concise. 0.72. What is the ratio of the Rent(as % of GDP) in Sudan in 1990 to that in 1996?
Keep it short and to the point. 0.03. What is the ratio of the Rent(as % of GDP) of Zambia in 1990 to that in 1996?
Give a very brief answer. 4.08. What is the ratio of the Rent(as % of GDP) of France in 1990 to that in 1997?
Make the answer very short. 17.83. What is the ratio of the Rent(as % of GDP) in Mongolia in 1990 to that in 1997?
Your answer should be compact. 0.63. What is the ratio of the Rent(as % of GDP) in Sudan in 1990 to that in 1997?
Your response must be concise. 0.38. What is the ratio of the Rent(as % of GDP) in Zambia in 1990 to that in 1997?
Provide a succinct answer. 3.95. What is the ratio of the Rent(as % of GDP) in France in 1991 to that in 1995?
Your response must be concise. 2.51. What is the ratio of the Rent(as % of GDP) in Mongolia in 1991 to that in 1995?
Your answer should be very brief. 0.31. What is the ratio of the Rent(as % of GDP) of Sudan in 1991 to that in 1995?
Offer a very short reply. 0.02. What is the ratio of the Rent(as % of GDP) in Zambia in 1991 to that in 1995?
Make the answer very short. 0.92. What is the ratio of the Rent(as % of GDP) in France in 1991 to that in 1996?
Make the answer very short. 1.59. What is the ratio of the Rent(as % of GDP) of Mongolia in 1991 to that in 1996?
Your answer should be compact. 0.45. What is the ratio of the Rent(as % of GDP) in Zambia in 1991 to that in 1996?
Make the answer very short. 2.03. What is the ratio of the Rent(as % of GDP) in France in 1991 to that in 1997?
Provide a succinct answer. 7.85. What is the ratio of the Rent(as % of GDP) in Mongolia in 1991 to that in 1997?
Your answer should be very brief. 0.39. What is the ratio of the Rent(as % of GDP) in Sudan in 1991 to that in 1997?
Provide a short and direct response. 0.15. What is the ratio of the Rent(as % of GDP) of Zambia in 1991 to that in 1997?
Offer a very short reply. 1.96. What is the ratio of the Rent(as % of GDP) in France in 1995 to that in 1996?
Your response must be concise. 0.63. What is the ratio of the Rent(as % of GDP) of Mongolia in 1995 to that in 1996?
Your answer should be very brief. 1.44. What is the ratio of the Rent(as % of GDP) of Sudan in 1995 to that in 1996?
Make the answer very short. 0.41. What is the ratio of the Rent(as % of GDP) of Zambia in 1995 to that in 1996?
Give a very brief answer. 2.21. What is the ratio of the Rent(as % of GDP) in France in 1995 to that in 1997?
Your answer should be compact. 3.13. What is the ratio of the Rent(as % of GDP) of Mongolia in 1995 to that in 1997?
Offer a very short reply. 1.27. What is the ratio of the Rent(as % of GDP) of Sudan in 1995 to that in 1997?
Make the answer very short. 6.18. What is the ratio of the Rent(as % of GDP) of Zambia in 1995 to that in 1997?
Your answer should be very brief. 2.13. What is the ratio of the Rent(as % of GDP) in France in 1996 to that in 1997?
Keep it short and to the point. 4.95. What is the ratio of the Rent(as % of GDP) of Mongolia in 1996 to that in 1997?
Give a very brief answer. 0.88. What is the ratio of the Rent(as % of GDP) in Sudan in 1996 to that in 1997?
Provide a short and direct response. 14.98. What is the ratio of the Rent(as % of GDP) in Zambia in 1996 to that in 1997?
Your answer should be very brief. 0.97. What is the difference between the highest and the second highest Rent(as % of GDP) in France?
Ensure brevity in your answer.  0. What is the difference between the highest and the second highest Rent(as % of GDP) of Mongolia?
Give a very brief answer. 2.71. What is the difference between the highest and the second highest Rent(as % of GDP) in Sudan?
Give a very brief answer. 0.04. What is the difference between the highest and the second highest Rent(as % of GDP) of Zambia?
Give a very brief answer. 2.12. What is the difference between the highest and the lowest Rent(as % of GDP) of France?
Offer a terse response. 0. What is the difference between the highest and the lowest Rent(as % of GDP) of Mongolia?
Provide a short and direct response. 8.82. What is the difference between the highest and the lowest Rent(as % of GDP) of Sudan?
Offer a terse response. 0.07. What is the difference between the highest and the lowest Rent(as % of GDP) of Zambia?
Offer a terse response. 13.89. 